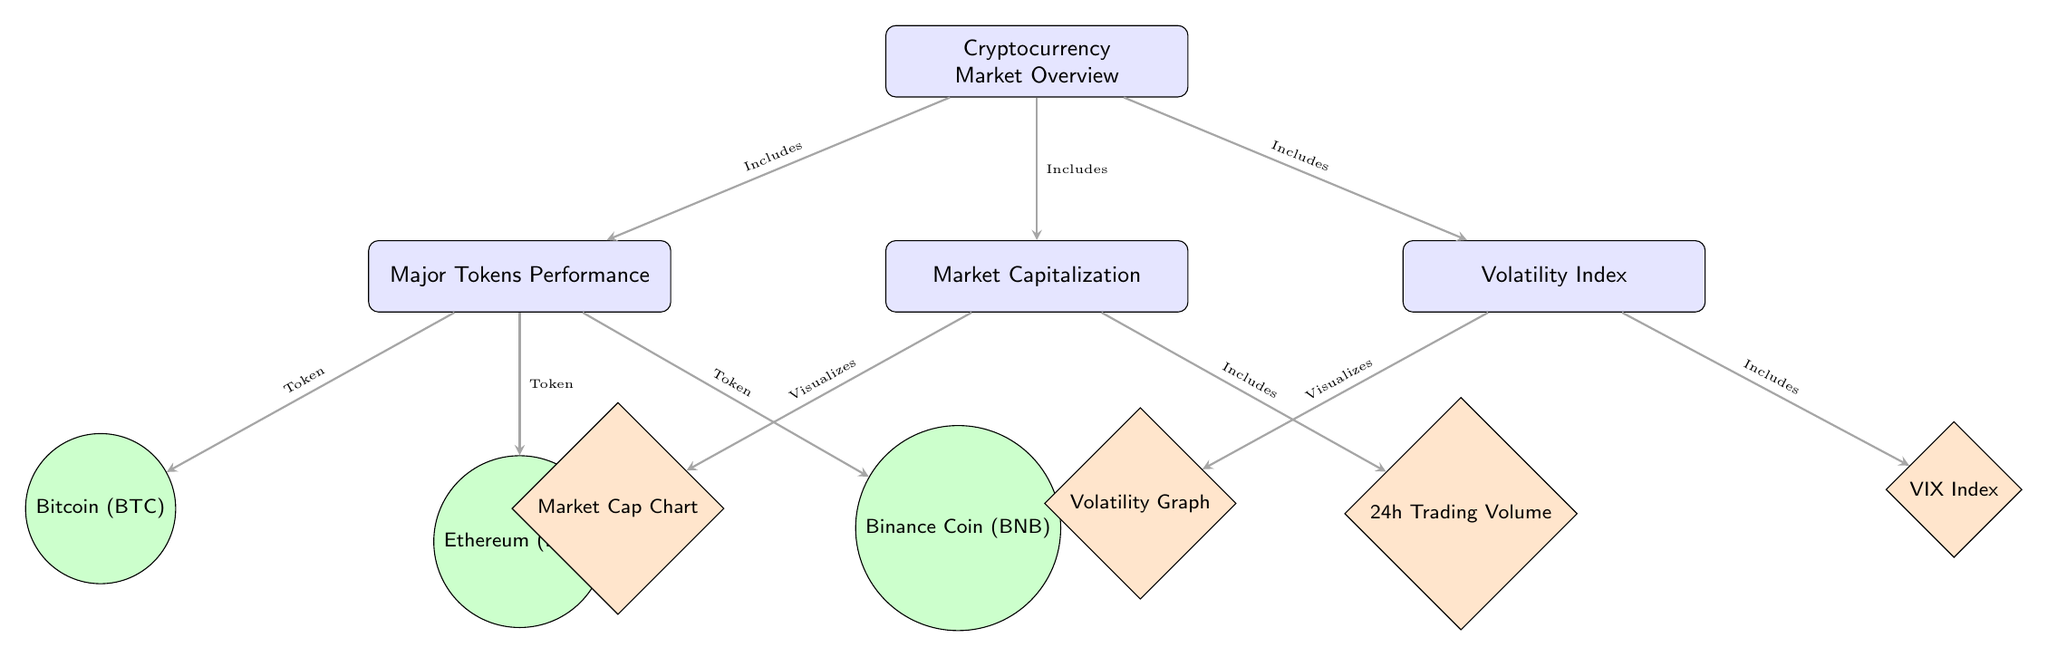What are the three major tokens listed under Performance? Under the "Major Tokens Performance" box, the diagram lists Bitcoin, Ethereum, and Binance Coin. By identifying the tokens indicated with circular nodes below the "Performance" box, we can directly name them.
Answer: Bitcoin, Ethereum, Binance Coin How many components are included in the Cryptocurrency Market Overview? The "Cryptocurrency Market Overview" box connects to three main components: Major Tokens Performance, Market Capitalization, and Volatility Index. Counting the arrows emanating from this box confirms the three parts included.
Answer: Three What type of chart is represented under Market Capitalization? Under the "Market Capitalization" box, the diagram shows a "Market Cap Chart" as one of the details, visually represented with a diamond node labeled accordingly.
Answer: Market Cap Chart What does the arrow connecting Volatility to Volatility Graph denote? The arrow pointing from the "Volatility Index" box to the "Volatility Graph" specifies that the graph visualizes data related to volatility. By tracking the direction of the arrow, it indicates the relationship between these two components.
Answer: Visualizes Which component includes the 24h Trading Volume? The "Market Capitalization" box contains a connection to the "24h Trading Volume" detail, indicated by the arrow pointing toward that specific chart node. Therefore, it is part of the market cap analysis.
Answer: 24h Trading Volume How many tokens are detailed under Major Tokens Performance? There are three tokens listed under the "Major Tokens Performance" box, specifically Bitcoin, Ethereum, and Binance Coin, each represented as a separate circular node connected to the main performance node.
Answer: Three What does the arrow between Market Capitalization and 24h Trading Volume signify? The arrow denotes that the 24h Trading Volume is included as part of the Market Capitalization analysis, illustrating the connection and relevance of trading volume in understanding market cap.
Answer: Includes Which component visualizes the Volatility Index? The "Volatility Index" itself is connected to the "VIX Index" node, indicating that the VIX Index is a specific detail associated with the overall volatility measures in the market.
Answer: VIX Index 